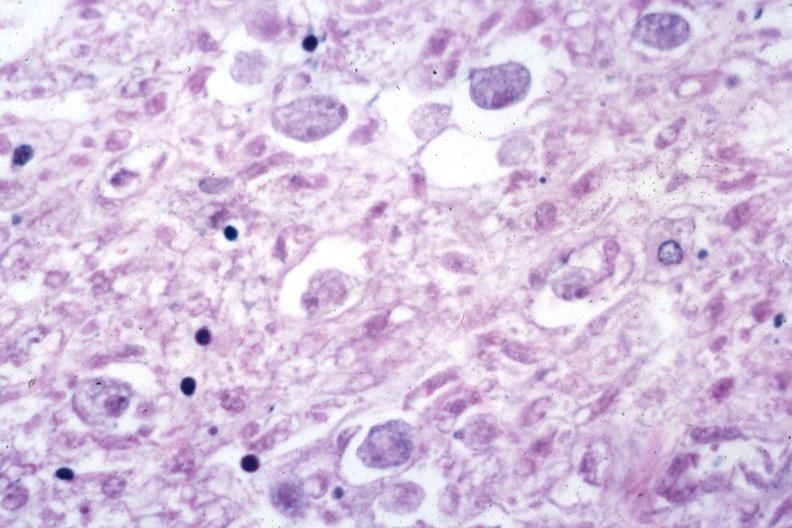s colon present?
Answer the question using a single word or phrase. Yes 